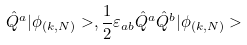Convert formula to latex. <formula><loc_0><loc_0><loc_500><loc_500>\hat { Q } ^ { a } | \phi _ { ( k , N ) } > , \frac { 1 } { 2 } \varepsilon _ { a b } \hat { Q } ^ { a } \hat { Q } ^ { b } | \phi _ { ( k , N ) } ></formula> 